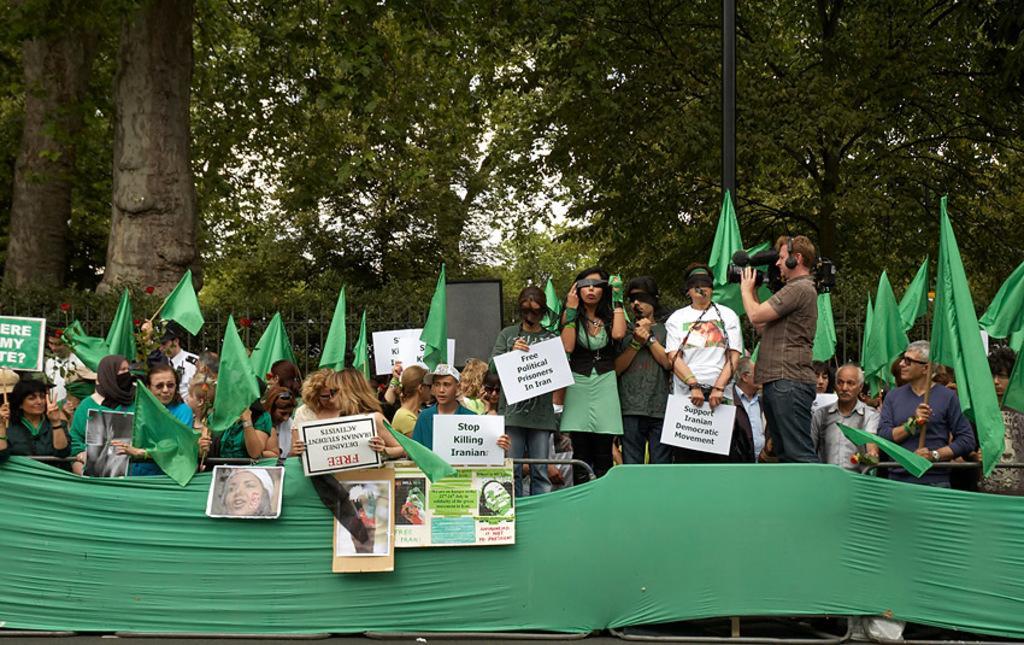Please provide a concise description of this image. To the bottom of the image there is a fencing with green color cloth. Behind the fencing there are many people standing with green flags, posters, banners and photos. And to the right side of the image there is a man with a video camera is standing. In the background there are trees and also there is a pole to the right side.  